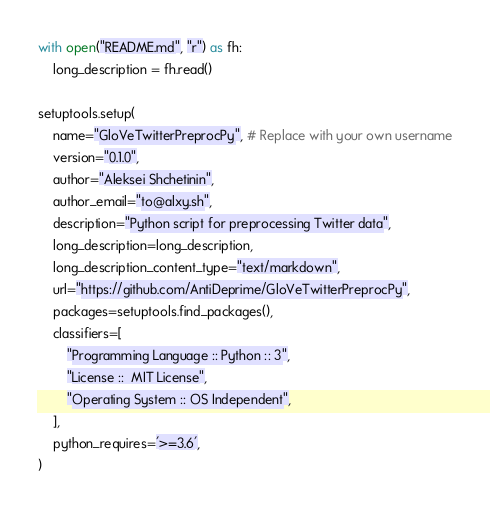Convert code to text. <code><loc_0><loc_0><loc_500><loc_500><_Python_>with open("README.md", "r") as fh:
    long_description = fh.read()

setuptools.setup(
    name="GloVeTwitterPreprocPy", # Replace with your own username
    version="0.1.0",
    author="Aleksei Shchetinin",
    author_email="to@alxy.sh",
    description="Python script for preprocessing Twitter data",
    long_description=long_description,
    long_description_content_type="text/markdown",
    url="https://github.com/AntiDeprime/GloVeTwitterPreprocPy",
    packages=setuptools.find_packages(),
    classifiers=[
        "Programming Language :: Python :: 3",
        "License ::  MIT License",
        "Operating System :: OS Independent",
    ],
    python_requires='>=3.6',
)</code> 